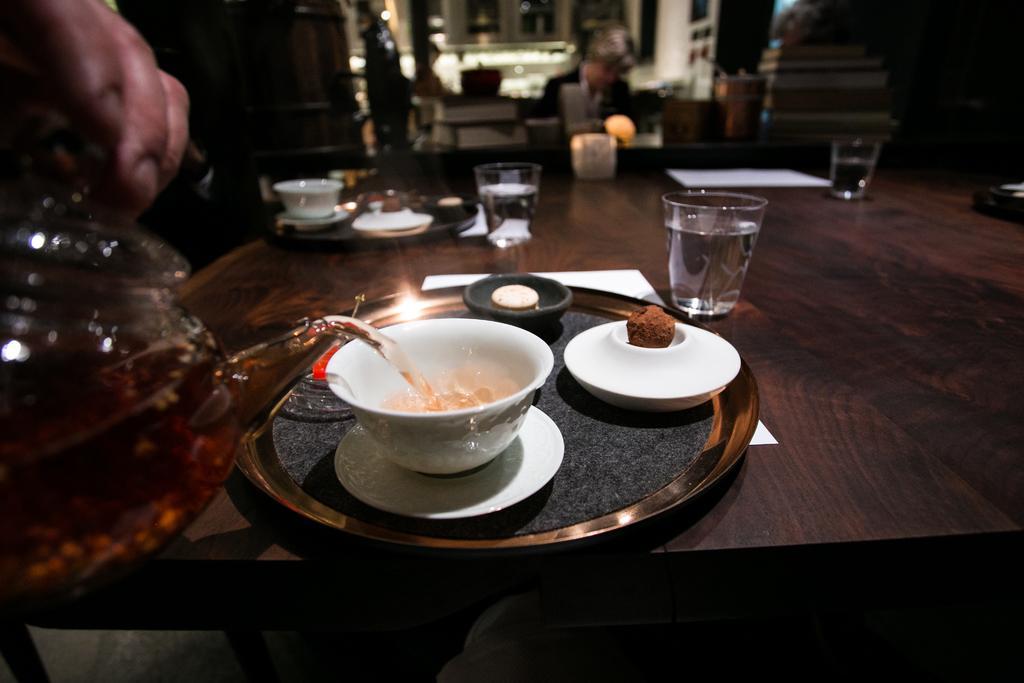Describe this image in one or two sentences. on the table there is a plate on which there is bowl, saucer, glass, paper. a person is pouring a drink in the bowl. 